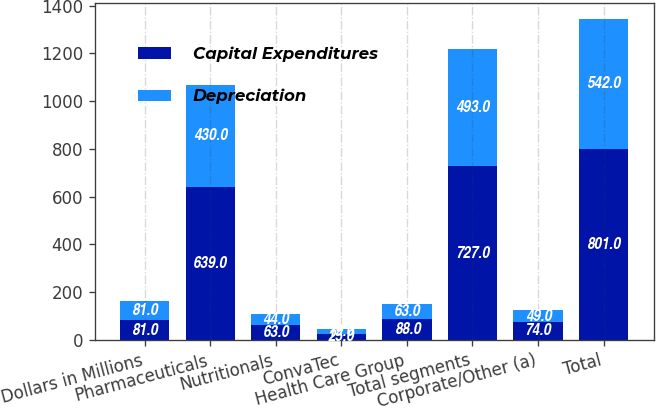Convert chart. <chart><loc_0><loc_0><loc_500><loc_500><stacked_bar_chart><ecel><fcel>Dollars in Millions<fcel>Pharmaceuticals<fcel>Nutritionals<fcel>ConvaTec<fcel>Health Care Group<fcel>Total segments<fcel>Corporate/Other (a)<fcel>Total<nl><fcel>Capital Expenditures<fcel>81<fcel>639<fcel>63<fcel>25<fcel>88<fcel>727<fcel>74<fcel>801<nl><fcel>Depreciation<fcel>81<fcel>430<fcel>44<fcel>19<fcel>63<fcel>493<fcel>49<fcel>542<nl></chart> 